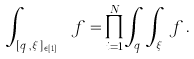Convert formula to latex. <formula><loc_0><loc_0><loc_500><loc_500>\int _ { [ q _ { i } , \xi _ { i } ] _ { i \in [ 1 , N ] } } f = \prod _ { i = 1 } ^ { N } \int _ { q _ { i } } \int _ { \xi _ { i } } \, f \, .</formula> 